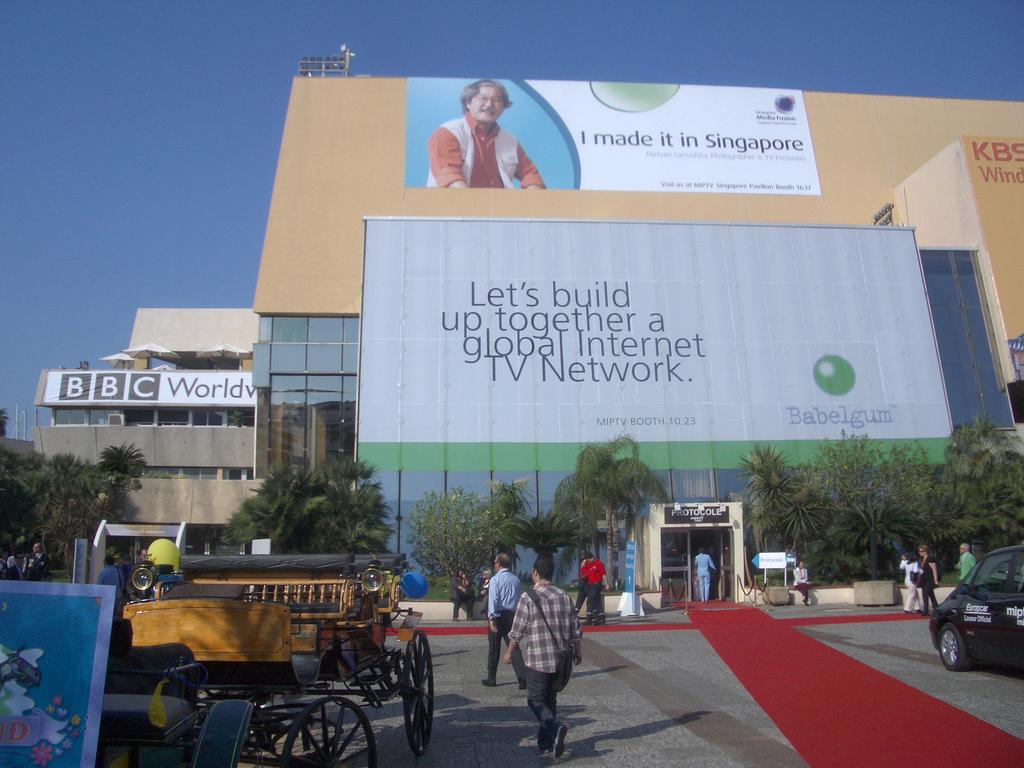<image>
Provide a brief description of the given image. The big ad in the middle is for the company Bablegum 